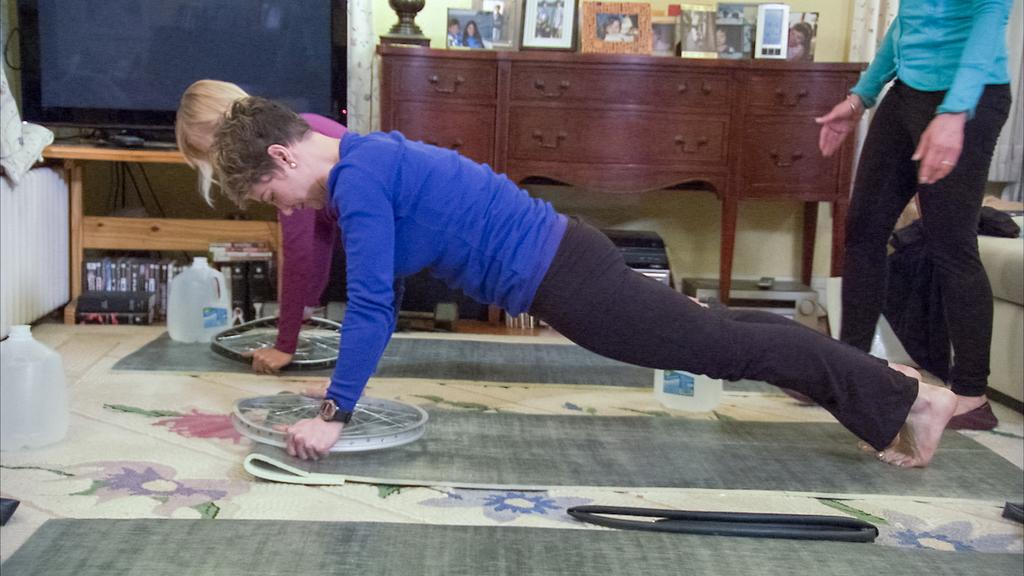What are the two women in the image doing? The two women in the image are working out. Can you describe the person standing at the right side of the image? There is another person standing at the right side of the image. What electronic device is present in the image? There is a television in the image. What type of furniture is visible in the image? There are objects placed on a wooden shelf in the image. What type of memory does the machine in the image have? There is no machine present in the image, so it is not possible to determine the type of memory it might have. 